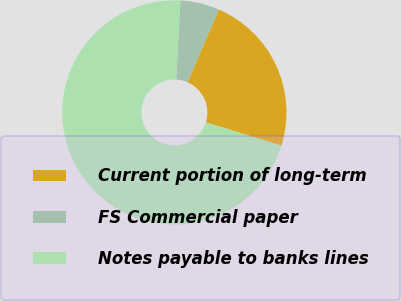Convert chart. <chart><loc_0><loc_0><loc_500><loc_500><pie_chart><fcel>Current portion of long-term<fcel>FS Commercial paper<fcel>Notes payable to banks lines<nl><fcel>23.3%<fcel>5.64%<fcel>71.06%<nl></chart> 